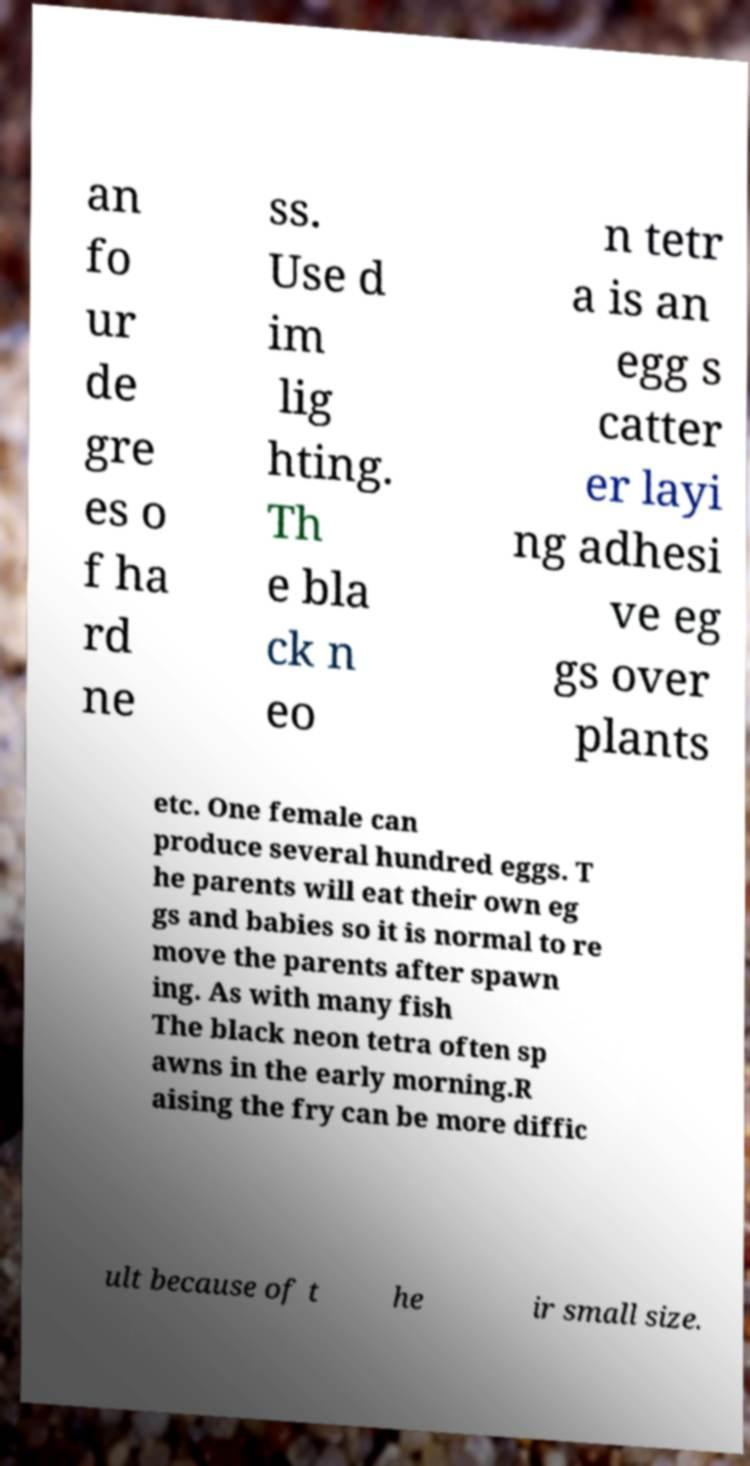What messages or text are displayed in this image? I need them in a readable, typed format. an fo ur de gre es o f ha rd ne ss. Use d im lig hting. Th e bla ck n eo n tetr a is an egg s catter er layi ng adhesi ve eg gs over plants etc. One female can produce several hundred eggs. T he parents will eat their own eg gs and babies so it is normal to re move the parents after spawn ing. As with many fish The black neon tetra often sp awns in the early morning.R aising the fry can be more diffic ult because of t he ir small size. 